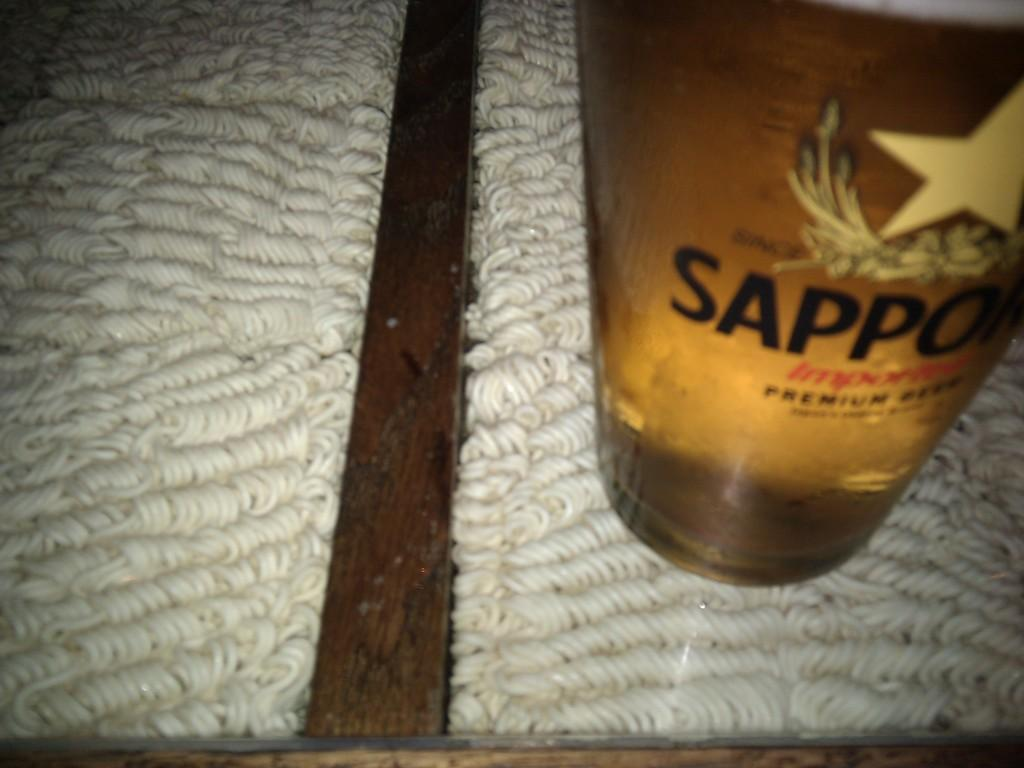What object is located on the table in the image? There is a bottle on the table in the image. What else can be seen in the image besides the bottle? There is food visible in the image. What is the belief of the skin in the image? There is no mention of skin or any beliefs in the image; it only features a bottle and food. 